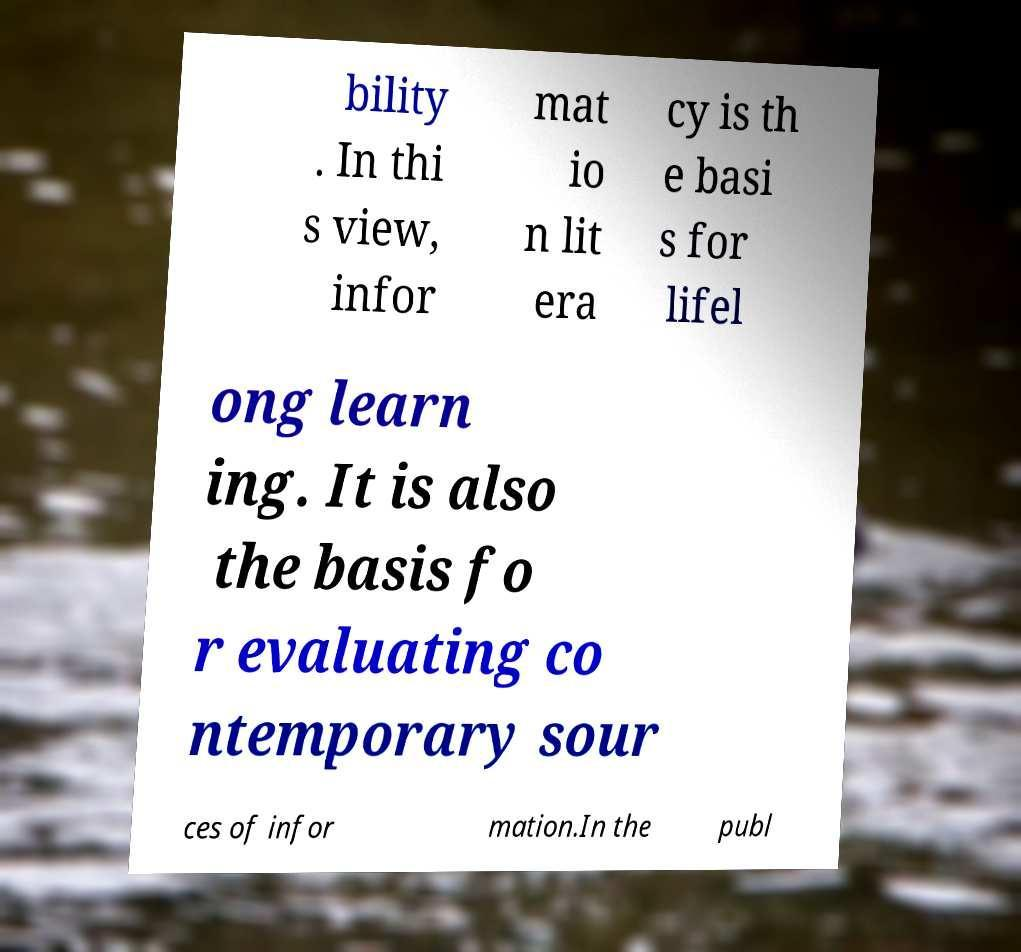Could you extract and type out the text from this image? bility . In thi s view, infor mat io n lit era cy is th e basi s for lifel ong learn ing. It is also the basis fo r evaluating co ntemporary sour ces of infor mation.In the publ 